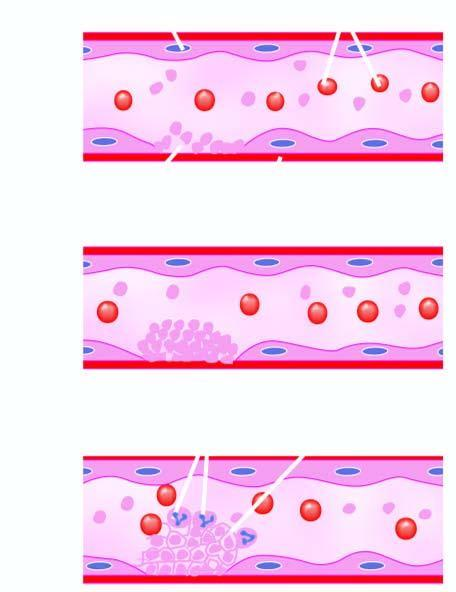does endothelial injury expose subendothelium, initiating adherence of platelets and activation of coagulation system?
Answer the question using a single word or phrase. Yes 